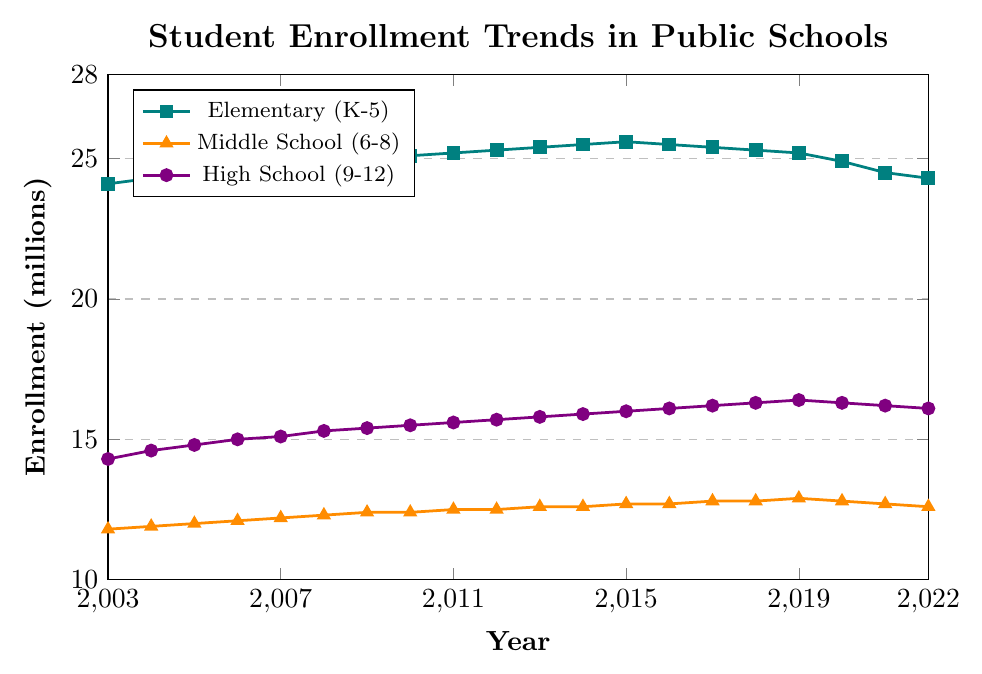What trend can you observe in the enrollment of Elementary (K-5) students from 2003 to 2022? The enrollment of Elementary (K-5) students shows a gradual increase from 24.1 million in 2003 to a peak of 25.6 million in 2015, and then a gradual decline to 24.3 million by 2022.
Answer: Gradual increase, then decline Which grade level had the highest enrollment in 2020? By examining the data points for 2020, it is clear that Elementary (K-5) had the highest enrollment at 24.9 million compared to Middle School (12.8 million) and High School (16.3 million).
Answer: Elementary (K-5) How much did the High School (9-12) enrollment increase from 2003 to 2019? High School enrollment increased from 14.3 million in 2003 to 16.4 million in 2019, representing an increase of 16.4 - 14.3 = 2.1 million.
Answer: 2.1 million Between which years did Middle School (6-8) enrollment remain constant? Middle School enrollment remained constant between 2009 and 2010, and again between 2011 and 2012, with enrollments of 12.4 and 12.5 million, respectively.
Answer: 2009-2010, 2011-2012 What is the average enrollment for Middle School (6-8) students from 2003 to 2022? The average can be calculated by summing all the Middle School enrollments from 2003 to 2022 and dividing by the number of years: (11.8 + 11.9 + 12.0 + 12.1 + 12.2 + 12.3 + 12.4 + 12.4 + 12.5 + 12.5 + 12.6 + 12.6 + 12.7 + 12.7 + 12.8 + 12.8 + 12.9 + 12.8 + 12.7 + 12.6) / 20 = 12.43 million.
Answer: 12.43 million Which year saw the peak enrollment for High School (9-12) students and what was the value? High School enrollment peaked in 2019 with 16.4 million students.
Answer: 2019, 16.4 million Comparing the Elementary and Middle School enrollments, which had a smaller change in enrollment from 2016 to 2020? Elementary enrollment decreased from 25.5 million to 24.9 million (a change of 0.6 million) and Middle School enrollment remained the same at 12.8 million. Therefore, Middle School had a smaller change.
Answer: Middle School (6-8) How does the trend in High School (9-12) enrollment around 2008 compare to that of Elementary (K-5) enrollment? Around 2008, both High School and Elementary enrollments show an increasing trend. High School enrollment increased from 15.1 million in 2007 to 15.3 million in 2008, while Elementary enrollment increased from 24.8 million to 24.9 million in the same period.
Answer: Both increasing What is the difference in enrollment between Elementary (K-5) and High School (9-12) students in 2022? Subtracting the High School enrollment in 2022 (16.1 million) from the Elementary enrollment in 2022 (24.3 million) gives a difference of 24.3 - 16.1 = 8.2 million.
Answer: 8.2 million 